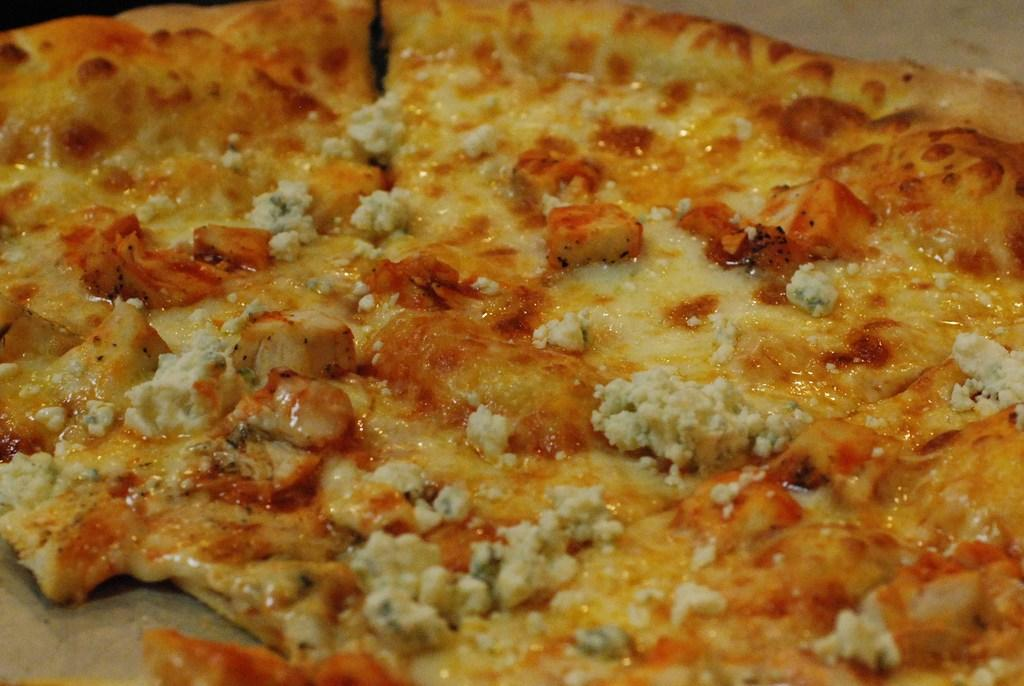What is the main food item visible in the image? There is a pizza in the image. What type of rake is being used to cut the pizza in the image? There is no rake present in the image, and the pizza is not being cut. What type of oil is drizzled on top of the pizza in the image? There is no oil visible on the pizza in the image. 